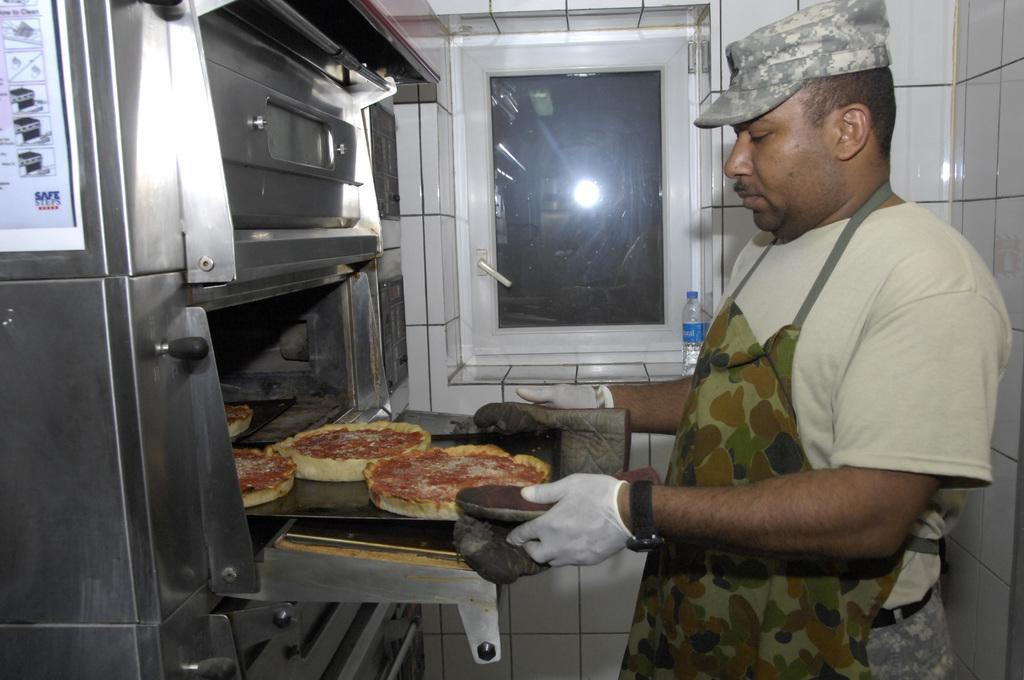<image>
Offer a succinct explanation of the picture presented. a safe sheet of paper next to a guy cooking 